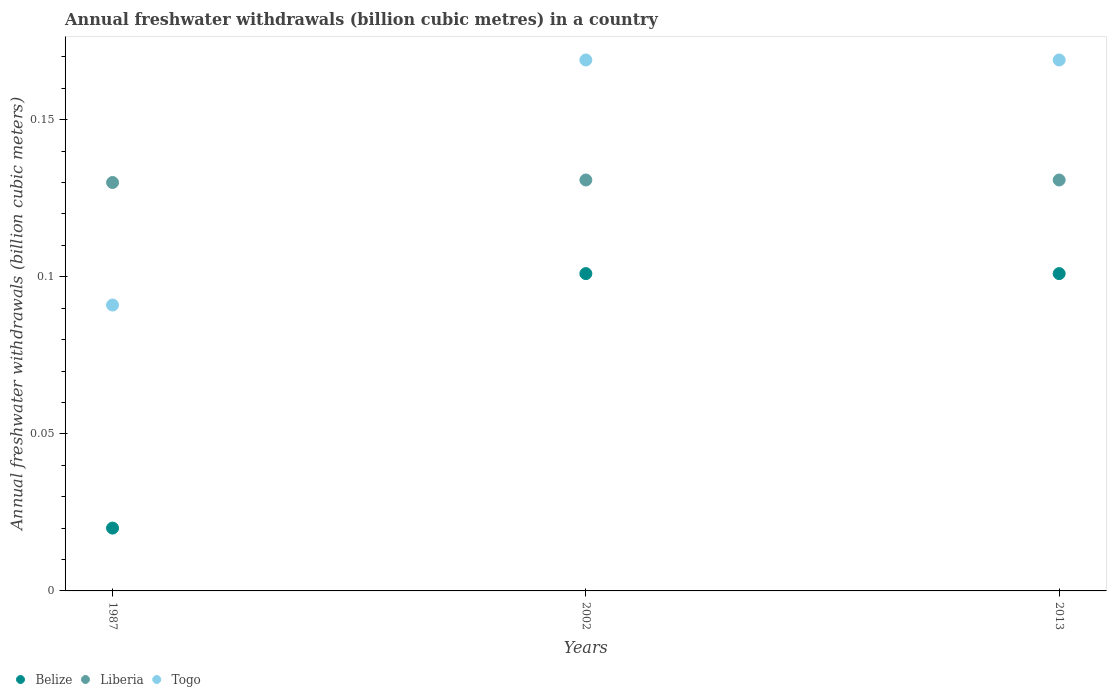What is the annual freshwater withdrawals in Belize in 2002?
Keep it short and to the point. 0.1. Across all years, what is the maximum annual freshwater withdrawals in Liberia?
Offer a very short reply. 0.13. Across all years, what is the minimum annual freshwater withdrawals in Liberia?
Your answer should be compact. 0.13. What is the total annual freshwater withdrawals in Togo in the graph?
Your answer should be compact. 0.43. What is the difference between the annual freshwater withdrawals in Belize in 2002 and the annual freshwater withdrawals in Togo in 2013?
Make the answer very short. -0.07. What is the average annual freshwater withdrawals in Liberia per year?
Keep it short and to the point. 0.13. In the year 2013, what is the difference between the annual freshwater withdrawals in Liberia and annual freshwater withdrawals in Togo?
Offer a very short reply. -0.04. What is the ratio of the annual freshwater withdrawals in Togo in 1987 to that in 2013?
Your answer should be very brief. 0.54. Is the annual freshwater withdrawals in Togo in 2002 less than that in 2013?
Provide a succinct answer. No. What is the difference between the highest and the second highest annual freshwater withdrawals in Liberia?
Make the answer very short. 0. What is the difference between the highest and the lowest annual freshwater withdrawals in Togo?
Offer a terse response. 0.08. In how many years, is the annual freshwater withdrawals in Togo greater than the average annual freshwater withdrawals in Togo taken over all years?
Your answer should be compact. 2. Is the sum of the annual freshwater withdrawals in Belize in 2002 and 2013 greater than the maximum annual freshwater withdrawals in Liberia across all years?
Your response must be concise. Yes. Is it the case that in every year, the sum of the annual freshwater withdrawals in Liberia and annual freshwater withdrawals in Togo  is greater than the annual freshwater withdrawals in Belize?
Ensure brevity in your answer.  Yes. Is the annual freshwater withdrawals in Togo strictly greater than the annual freshwater withdrawals in Liberia over the years?
Ensure brevity in your answer.  No. Is the annual freshwater withdrawals in Belize strictly less than the annual freshwater withdrawals in Togo over the years?
Provide a succinct answer. Yes. How many years are there in the graph?
Provide a short and direct response. 3. What is the title of the graph?
Offer a very short reply. Annual freshwater withdrawals (billion cubic metres) in a country. What is the label or title of the X-axis?
Your answer should be compact. Years. What is the label or title of the Y-axis?
Offer a very short reply. Annual freshwater withdrawals (billion cubic meters). What is the Annual freshwater withdrawals (billion cubic meters) of Belize in 1987?
Your answer should be compact. 0.02. What is the Annual freshwater withdrawals (billion cubic meters) of Liberia in 1987?
Offer a very short reply. 0.13. What is the Annual freshwater withdrawals (billion cubic meters) of Togo in 1987?
Ensure brevity in your answer.  0.09. What is the Annual freshwater withdrawals (billion cubic meters) of Belize in 2002?
Offer a very short reply. 0.1. What is the Annual freshwater withdrawals (billion cubic meters) in Liberia in 2002?
Ensure brevity in your answer.  0.13. What is the Annual freshwater withdrawals (billion cubic meters) of Togo in 2002?
Your answer should be very brief. 0.17. What is the Annual freshwater withdrawals (billion cubic meters) in Belize in 2013?
Make the answer very short. 0.1. What is the Annual freshwater withdrawals (billion cubic meters) of Liberia in 2013?
Provide a short and direct response. 0.13. What is the Annual freshwater withdrawals (billion cubic meters) of Togo in 2013?
Your response must be concise. 0.17. Across all years, what is the maximum Annual freshwater withdrawals (billion cubic meters) in Belize?
Give a very brief answer. 0.1. Across all years, what is the maximum Annual freshwater withdrawals (billion cubic meters) in Liberia?
Offer a very short reply. 0.13. Across all years, what is the maximum Annual freshwater withdrawals (billion cubic meters) in Togo?
Offer a very short reply. 0.17. Across all years, what is the minimum Annual freshwater withdrawals (billion cubic meters) of Belize?
Offer a very short reply. 0.02. Across all years, what is the minimum Annual freshwater withdrawals (billion cubic meters) in Liberia?
Your response must be concise. 0.13. Across all years, what is the minimum Annual freshwater withdrawals (billion cubic meters) in Togo?
Provide a succinct answer. 0.09. What is the total Annual freshwater withdrawals (billion cubic meters) in Belize in the graph?
Offer a terse response. 0.22. What is the total Annual freshwater withdrawals (billion cubic meters) of Liberia in the graph?
Your response must be concise. 0.39. What is the total Annual freshwater withdrawals (billion cubic meters) of Togo in the graph?
Your response must be concise. 0.43. What is the difference between the Annual freshwater withdrawals (billion cubic meters) in Belize in 1987 and that in 2002?
Keep it short and to the point. -0.08. What is the difference between the Annual freshwater withdrawals (billion cubic meters) of Liberia in 1987 and that in 2002?
Keep it short and to the point. -0. What is the difference between the Annual freshwater withdrawals (billion cubic meters) in Togo in 1987 and that in 2002?
Your answer should be very brief. -0.08. What is the difference between the Annual freshwater withdrawals (billion cubic meters) in Belize in 1987 and that in 2013?
Your answer should be very brief. -0.08. What is the difference between the Annual freshwater withdrawals (billion cubic meters) in Liberia in 1987 and that in 2013?
Offer a very short reply. -0. What is the difference between the Annual freshwater withdrawals (billion cubic meters) of Togo in 1987 and that in 2013?
Make the answer very short. -0.08. What is the difference between the Annual freshwater withdrawals (billion cubic meters) in Togo in 2002 and that in 2013?
Provide a short and direct response. 0. What is the difference between the Annual freshwater withdrawals (billion cubic meters) of Belize in 1987 and the Annual freshwater withdrawals (billion cubic meters) of Liberia in 2002?
Ensure brevity in your answer.  -0.11. What is the difference between the Annual freshwater withdrawals (billion cubic meters) of Belize in 1987 and the Annual freshwater withdrawals (billion cubic meters) of Togo in 2002?
Give a very brief answer. -0.15. What is the difference between the Annual freshwater withdrawals (billion cubic meters) of Liberia in 1987 and the Annual freshwater withdrawals (billion cubic meters) of Togo in 2002?
Offer a terse response. -0.04. What is the difference between the Annual freshwater withdrawals (billion cubic meters) in Belize in 1987 and the Annual freshwater withdrawals (billion cubic meters) in Liberia in 2013?
Offer a terse response. -0.11. What is the difference between the Annual freshwater withdrawals (billion cubic meters) of Belize in 1987 and the Annual freshwater withdrawals (billion cubic meters) of Togo in 2013?
Ensure brevity in your answer.  -0.15. What is the difference between the Annual freshwater withdrawals (billion cubic meters) in Liberia in 1987 and the Annual freshwater withdrawals (billion cubic meters) in Togo in 2013?
Provide a short and direct response. -0.04. What is the difference between the Annual freshwater withdrawals (billion cubic meters) in Belize in 2002 and the Annual freshwater withdrawals (billion cubic meters) in Liberia in 2013?
Your response must be concise. -0.03. What is the difference between the Annual freshwater withdrawals (billion cubic meters) in Belize in 2002 and the Annual freshwater withdrawals (billion cubic meters) in Togo in 2013?
Ensure brevity in your answer.  -0.07. What is the difference between the Annual freshwater withdrawals (billion cubic meters) of Liberia in 2002 and the Annual freshwater withdrawals (billion cubic meters) of Togo in 2013?
Offer a very short reply. -0.04. What is the average Annual freshwater withdrawals (billion cubic meters) of Belize per year?
Make the answer very short. 0.07. What is the average Annual freshwater withdrawals (billion cubic meters) in Liberia per year?
Your answer should be very brief. 0.13. What is the average Annual freshwater withdrawals (billion cubic meters) in Togo per year?
Ensure brevity in your answer.  0.14. In the year 1987, what is the difference between the Annual freshwater withdrawals (billion cubic meters) of Belize and Annual freshwater withdrawals (billion cubic meters) of Liberia?
Ensure brevity in your answer.  -0.11. In the year 1987, what is the difference between the Annual freshwater withdrawals (billion cubic meters) in Belize and Annual freshwater withdrawals (billion cubic meters) in Togo?
Ensure brevity in your answer.  -0.07. In the year 1987, what is the difference between the Annual freshwater withdrawals (billion cubic meters) of Liberia and Annual freshwater withdrawals (billion cubic meters) of Togo?
Provide a short and direct response. 0.04. In the year 2002, what is the difference between the Annual freshwater withdrawals (billion cubic meters) in Belize and Annual freshwater withdrawals (billion cubic meters) in Liberia?
Provide a short and direct response. -0.03. In the year 2002, what is the difference between the Annual freshwater withdrawals (billion cubic meters) in Belize and Annual freshwater withdrawals (billion cubic meters) in Togo?
Offer a terse response. -0.07. In the year 2002, what is the difference between the Annual freshwater withdrawals (billion cubic meters) of Liberia and Annual freshwater withdrawals (billion cubic meters) of Togo?
Offer a terse response. -0.04. In the year 2013, what is the difference between the Annual freshwater withdrawals (billion cubic meters) in Belize and Annual freshwater withdrawals (billion cubic meters) in Liberia?
Offer a very short reply. -0.03. In the year 2013, what is the difference between the Annual freshwater withdrawals (billion cubic meters) in Belize and Annual freshwater withdrawals (billion cubic meters) in Togo?
Provide a succinct answer. -0.07. In the year 2013, what is the difference between the Annual freshwater withdrawals (billion cubic meters) of Liberia and Annual freshwater withdrawals (billion cubic meters) of Togo?
Your answer should be very brief. -0.04. What is the ratio of the Annual freshwater withdrawals (billion cubic meters) in Belize in 1987 to that in 2002?
Ensure brevity in your answer.  0.2. What is the ratio of the Annual freshwater withdrawals (billion cubic meters) in Togo in 1987 to that in 2002?
Offer a terse response. 0.54. What is the ratio of the Annual freshwater withdrawals (billion cubic meters) in Belize in 1987 to that in 2013?
Your response must be concise. 0.2. What is the ratio of the Annual freshwater withdrawals (billion cubic meters) of Togo in 1987 to that in 2013?
Your answer should be compact. 0.54. What is the ratio of the Annual freshwater withdrawals (billion cubic meters) in Belize in 2002 to that in 2013?
Provide a short and direct response. 1. What is the ratio of the Annual freshwater withdrawals (billion cubic meters) of Liberia in 2002 to that in 2013?
Keep it short and to the point. 1. What is the difference between the highest and the second highest Annual freshwater withdrawals (billion cubic meters) of Belize?
Your response must be concise. 0. What is the difference between the highest and the second highest Annual freshwater withdrawals (billion cubic meters) of Liberia?
Provide a short and direct response. 0. What is the difference between the highest and the lowest Annual freshwater withdrawals (billion cubic meters) in Belize?
Provide a short and direct response. 0.08. What is the difference between the highest and the lowest Annual freshwater withdrawals (billion cubic meters) of Liberia?
Make the answer very short. 0. What is the difference between the highest and the lowest Annual freshwater withdrawals (billion cubic meters) in Togo?
Provide a succinct answer. 0.08. 